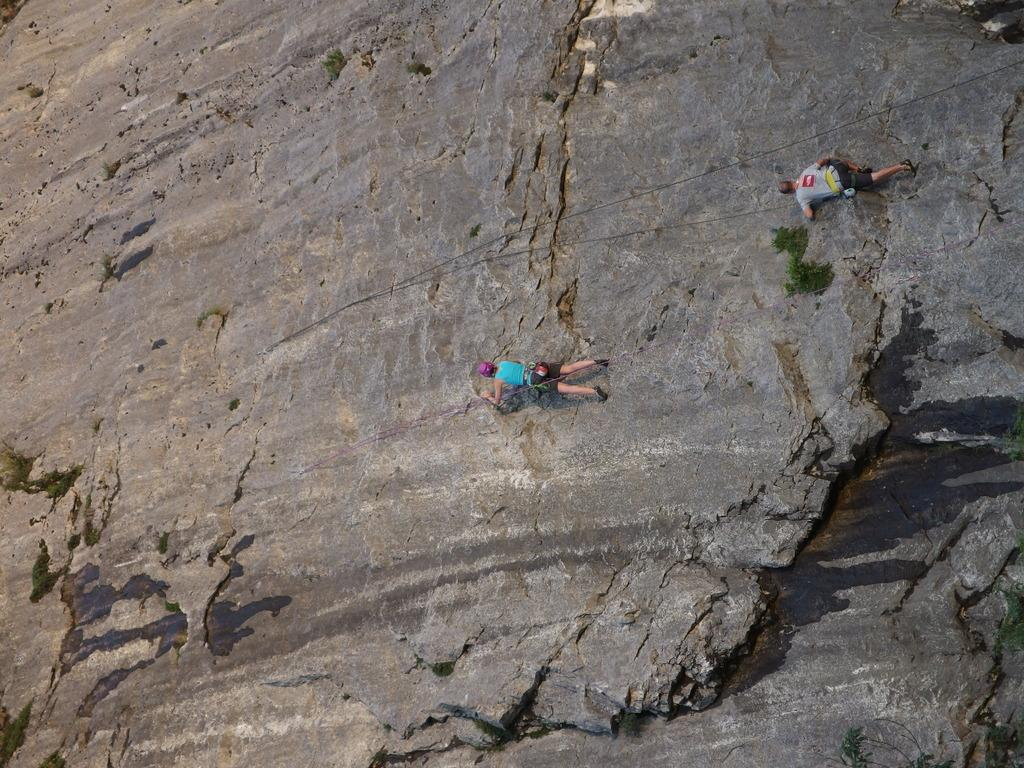How many people are in the image? There are two persons in the image. What are the persons doing in the image? The persons are trekking on a rock hill. What equipment are the persons using for their activity? The persons are using ropes. What natural element can be seen in the image? There is water visible in the image. What type of crayon is being used by the persons in the image? There are no crayons present in the image; the persons are using ropes for their activity. 